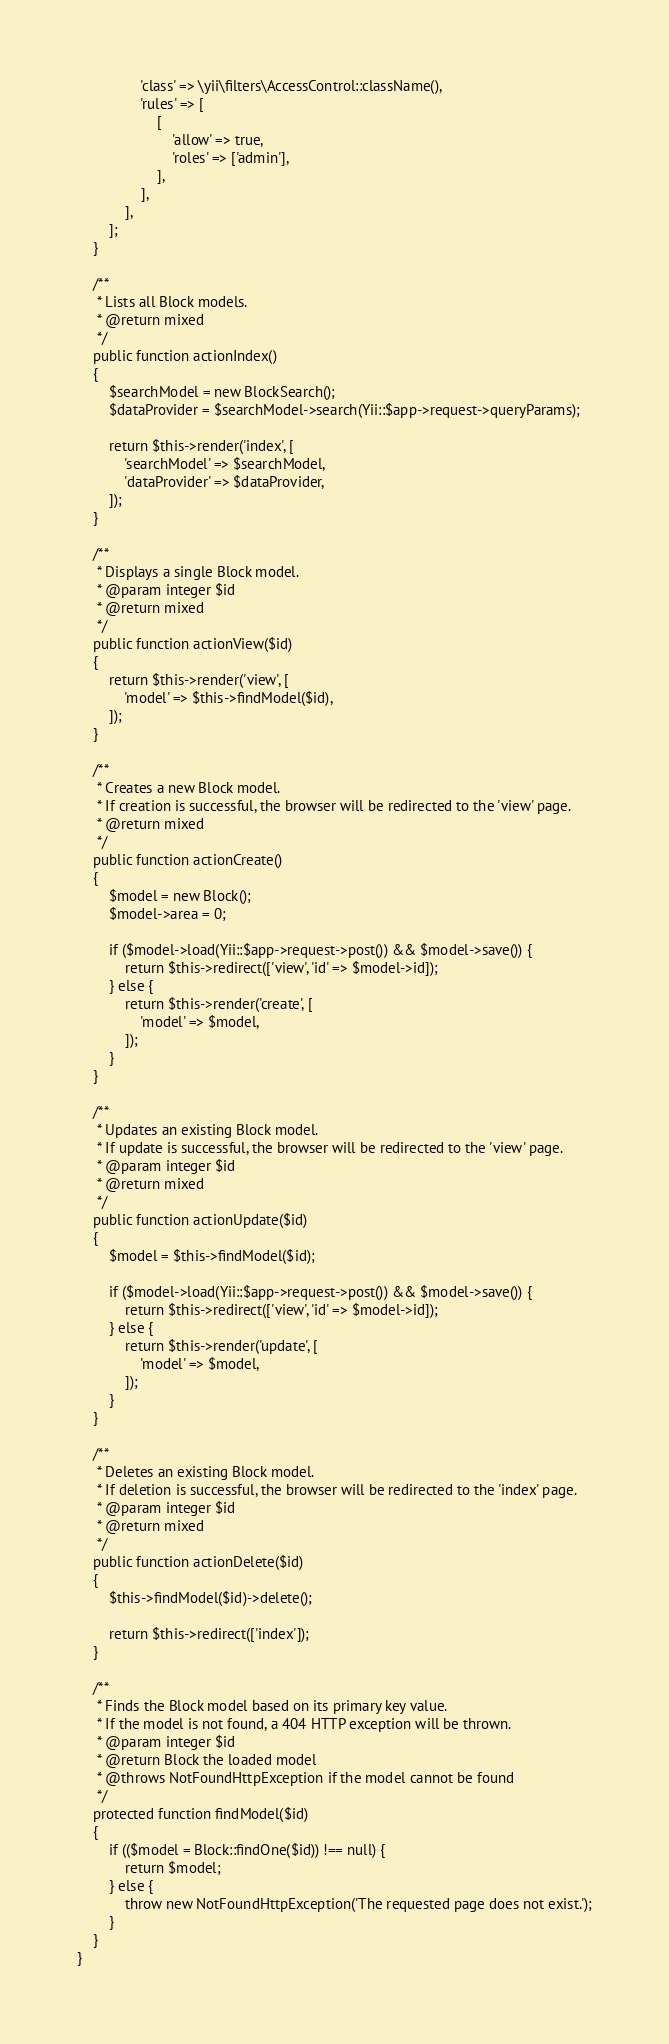<code> <loc_0><loc_0><loc_500><loc_500><_PHP_>                'class' => \yii\filters\AccessControl::className(),
                'rules' => [
                    [
                        'allow' => true,
                        'roles' => ['admin'],
                    ],
                ],
            ],
        ];
    }

    /**
     * Lists all Block models.
     * @return mixed
     */
    public function actionIndex()
    {
        $searchModel = new BlockSearch();
        $dataProvider = $searchModel->search(Yii::$app->request->queryParams);

        return $this->render('index', [
            'searchModel' => $searchModel,
            'dataProvider' => $dataProvider,
        ]);
    }

    /**
     * Displays a single Block model.
     * @param integer $id
     * @return mixed
     */
    public function actionView($id)
    {
        return $this->render('view', [
            'model' => $this->findModel($id),
        ]);
    }

    /**
     * Creates a new Block model.
     * If creation is successful, the browser will be redirected to the 'view' page.
     * @return mixed
     */
    public function actionCreate()
    {
        $model = new Block();
        $model->area = 0;

        if ($model->load(Yii::$app->request->post()) && $model->save()) {
            return $this->redirect(['view', 'id' => $model->id]);
        } else {
            return $this->render('create', [
                'model' => $model,
            ]);
        }
    }

    /**
     * Updates an existing Block model.
     * If update is successful, the browser will be redirected to the 'view' page.
     * @param integer $id
     * @return mixed
     */
    public function actionUpdate($id)
    {
        $model = $this->findModel($id);

        if ($model->load(Yii::$app->request->post()) && $model->save()) {
            return $this->redirect(['view', 'id' => $model->id]);
        } else {
            return $this->render('update', [
                'model' => $model,
            ]);
        }
    }

    /**
     * Deletes an existing Block model.
     * If deletion is successful, the browser will be redirected to the 'index' page.
     * @param integer $id
     * @return mixed
     */
    public function actionDelete($id)
    {
        $this->findModel($id)->delete();

        return $this->redirect(['index']);
    }

    /**
     * Finds the Block model based on its primary key value.
     * If the model is not found, a 404 HTTP exception will be thrown.
     * @param integer $id
     * @return Block the loaded model
     * @throws NotFoundHttpException if the model cannot be found
     */
    protected function findModel($id)
    {
        if (($model = Block::findOne($id)) !== null) {
            return $model;
        } else {
            throw new NotFoundHttpException('The requested page does not exist.');
        }
    }
}
</code> 